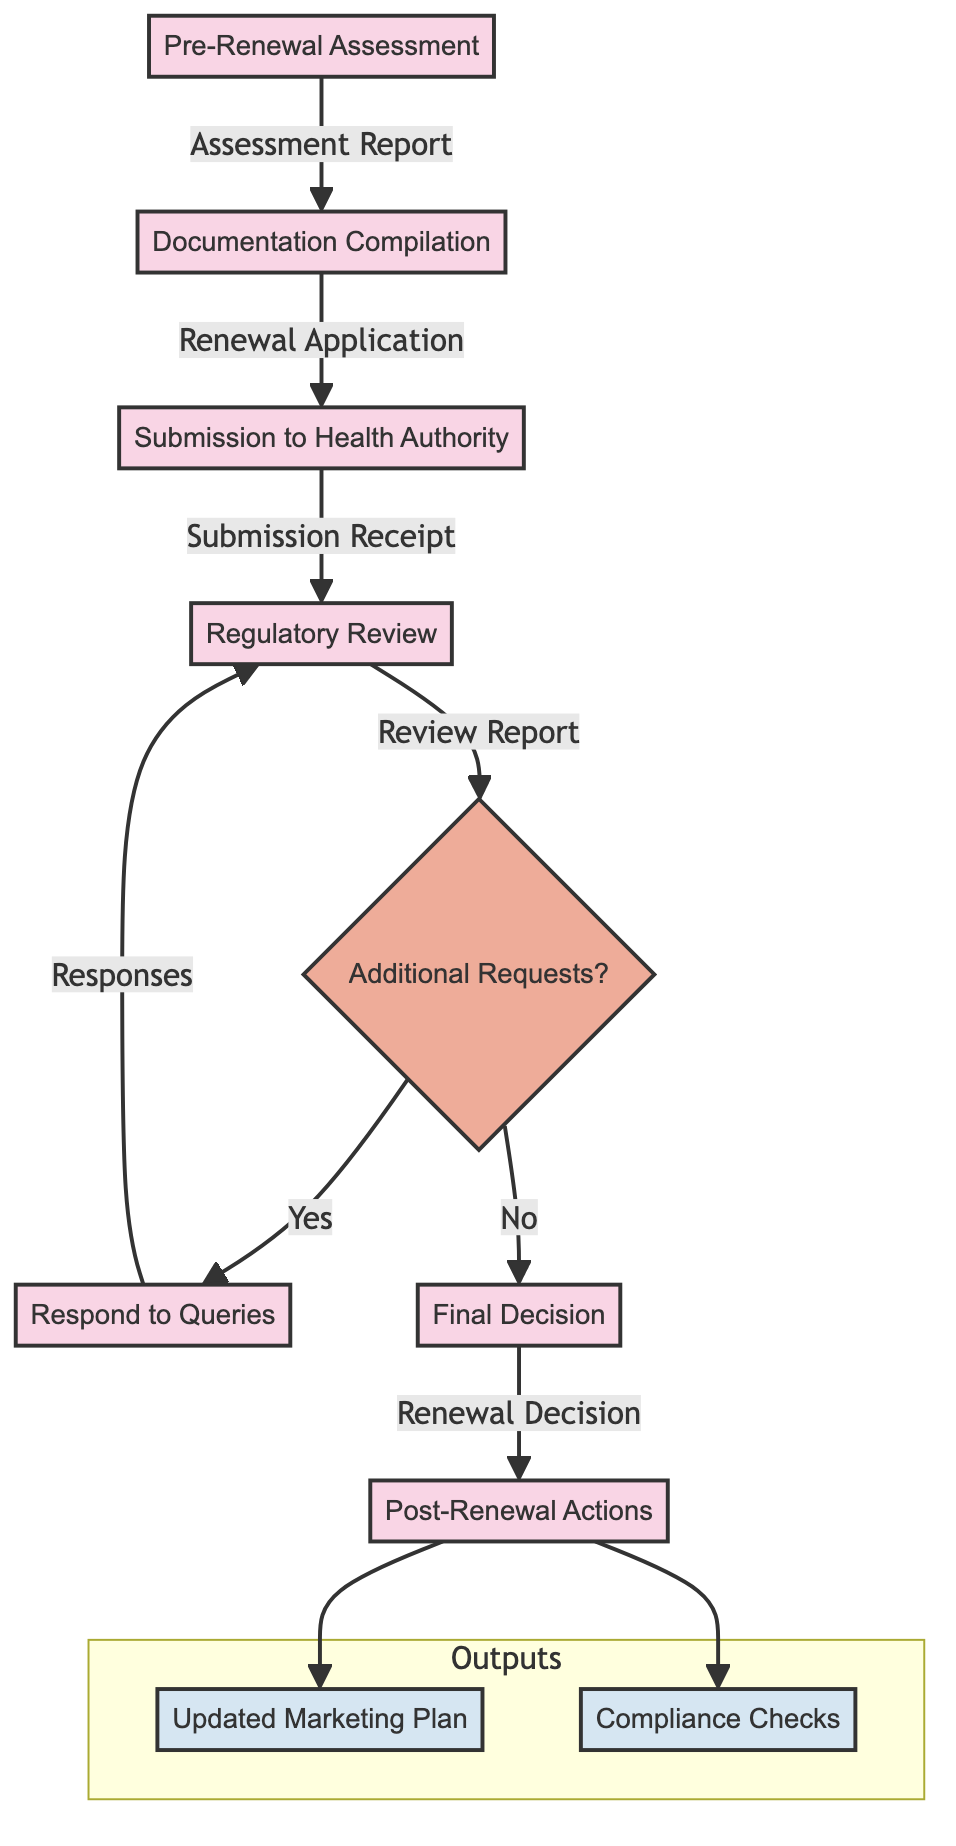What is the first step in the process? The first step in the diagram is labeled "Pre-Renewal Assessment," indicating it is the initial action in the Drug Marketing Authorization Renewal Process.
Answer: Pre-Renewal Assessment How many total steps are in the diagram? By counting the nodes or steps in the flowchart from start to finish, there are seven distinct steps in the Drug Marketing Authorization Renewal Process.
Answer: 7 What is the output of the "Submission to Health Authority" step? The output of the "Submission to Health Authority" step is the "Submission Receipt," which indicates that the application has been submitted and acknowledged by the authority.
Answer: Submission Receipt What follows if there are additional requests in the "Regulatory Review" step? If there are additional requests in the "Regulatory Review" step, the process leads to the "Respond to Queries" step to address those requests.
Answer: Respond to Queries What are the outputs of the final step "Post-Renewal Actions"? The outputs of the final step "Post-Renewal Actions" are "Updated Marketing Plan" and "Compliance Checks," both of which indicate actions taken after receiving the renewal decision.
Answer: Updated Marketing Plan, Compliance Checks What is the connection between "Regulatory Review" and "Final Decision"? The connection indicates that the "Regulatory Review" provides input to the "Final Decision," where decisions depend on the review report and any responses submitted.
Answer: Final Decision Which departments are involved in the "Documentation Compilation" step? The departments involved in the "Documentation Compilation" step include "Regulatory Affairs" and "Clinical Development" as they compile necessary documentation for renewal.
Answer: Regulatory Affairs, Clinical Development 